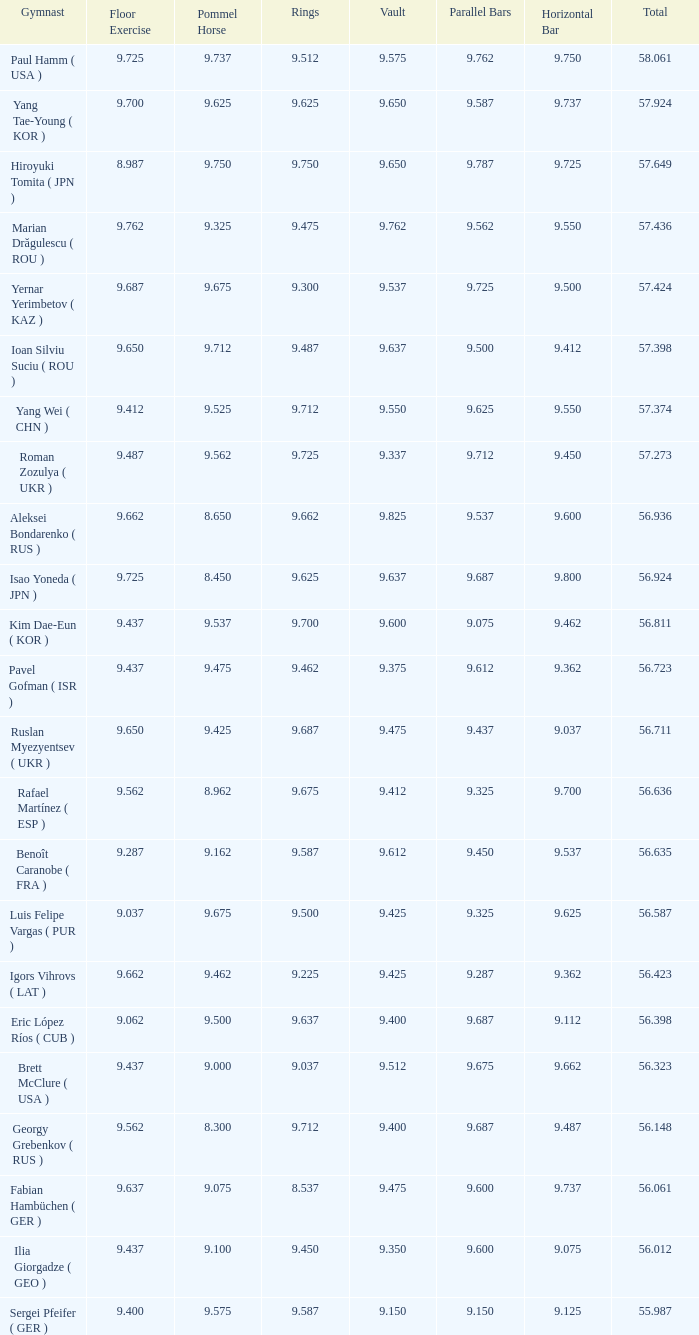What is the vault score for the total of 56.635? 9.612. 